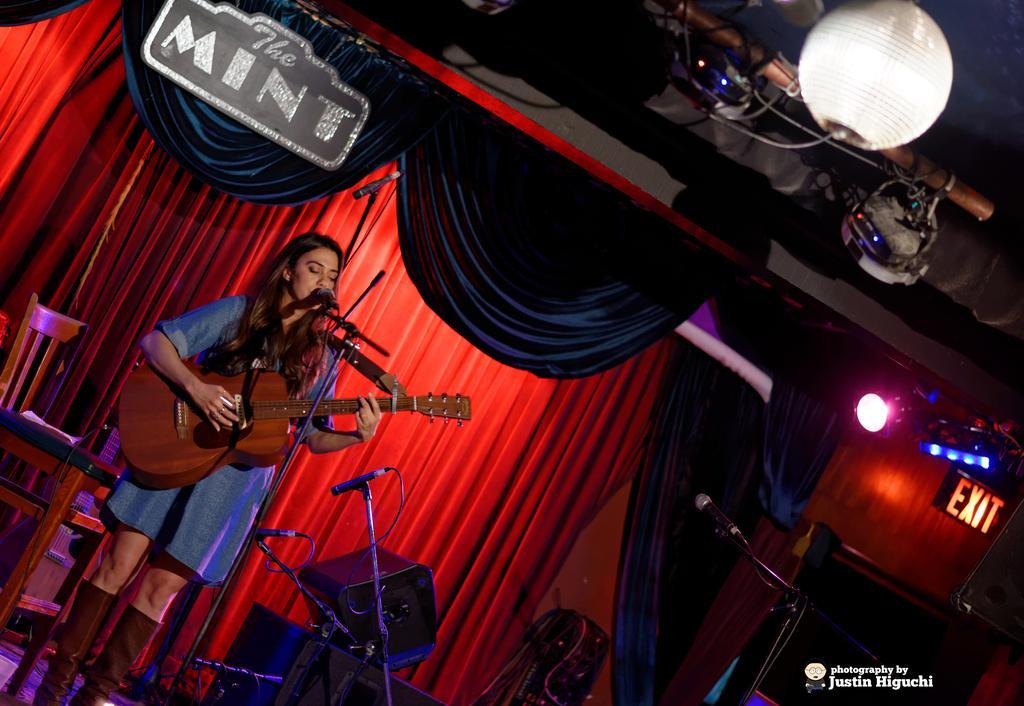Could you give a brief overview of what you see in this image? A woman is playing guitar and singing in-front of mic. Background there are curtains, board, focusing lights, disco light and chair. Bottom of the image we can see signboard, mic stands along with mic and devices. Right side bottom of the image there is a watermark. 